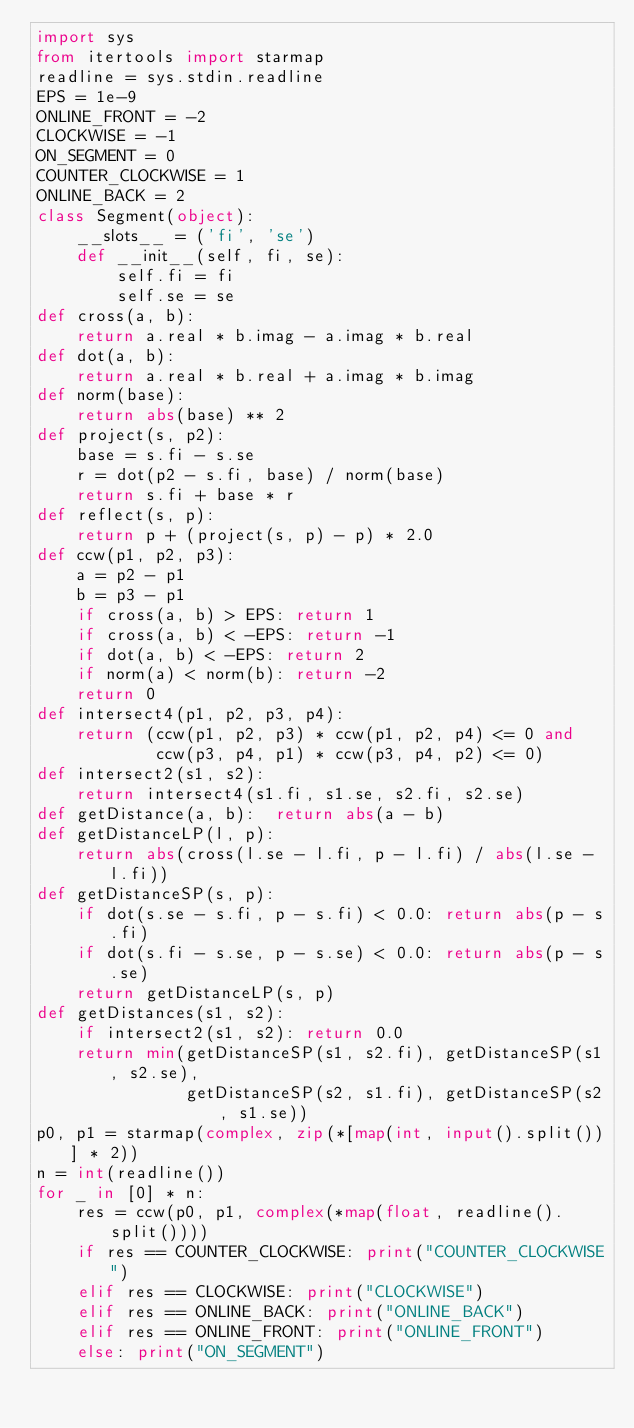<code> <loc_0><loc_0><loc_500><loc_500><_Python_>import sys
from itertools import starmap
readline = sys.stdin.readline
EPS = 1e-9
ONLINE_FRONT = -2
CLOCKWISE = -1
ON_SEGMENT = 0
COUNTER_CLOCKWISE = 1
ONLINE_BACK = 2
class Segment(object):
    __slots__ = ('fi', 'se')
    def __init__(self, fi, se):
        self.fi = fi
        self.se = se
def cross(a, b):
    return a.real * b.imag - a.imag * b.real
def dot(a, b):
    return a.real * b.real + a.imag * b.imag
def norm(base):
    return abs(base) ** 2
def project(s, p2):
    base = s.fi - s.se
    r = dot(p2 - s.fi, base) / norm(base)
    return s.fi + base * r
def reflect(s, p):
    return p + (project(s, p) - p) * 2.0
def ccw(p1, p2, p3):
    a = p2 - p1
    b = p3 - p1
    if cross(a, b) > EPS: return 1
    if cross(a, b) < -EPS: return -1
    if dot(a, b) < -EPS: return 2
    if norm(a) < norm(b): return -2
    return 0
def intersect4(p1, p2, p3, p4):
    return (ccw(p1, p2, p3) * ccw(p1, p2, p4) <= 0 and
			ccw(p3, p4, p1) * ccw(p3, p4, p2) <= 0)
def intersect2(s1, s2):
    return intersect4(s1.fi, s1.se, s2.fi, s2.se)
def getDistance(a, b):  return abs(a - b)
def getDistanceLP(l, p):
    return abs(cross(l.se - l.fi, p - l.fi) / abs(l.se - l.fi))
def getDistanceSP(s, p):
    if dot(s.se - s.fi, p - s.fi) < 0.0: return abs(p - s.fi)
    if dot(s.fi - s.se, p - s.se) < 0.0: return abs(p - s.se)
    return getDistanceLP(s, p)
def getDistances(s1, s2):
    if intersect2(s1, s2): return 0.0
    return min(getDistanceSP(s1, s2.fi), getDistanceSP(s1, s2.se),
               getDistanceSP(s2, s1.fi), getDistanceSP(s2, s1.se))
p0, p1 = starmap(complex, zip(*[map(int, input().split())] * 2))
n = int(readline())
for _ in [0] * n:
    res = ccw(p0, p1, complex(*map(float, readline().split())))
    if res == COUNTER_CLOCKWISE: print("COUNTER_CLOCKWISE")
    elif res == CLOCKWISE: print("CLOCKWISE")
    elif res == ONLINE_BACK: print("ONLINE_BACK")
    elif res == ONLINE_FRONT: print("ONLINE_FRONT")
    else: print("ON_SEGMENT")</code> 